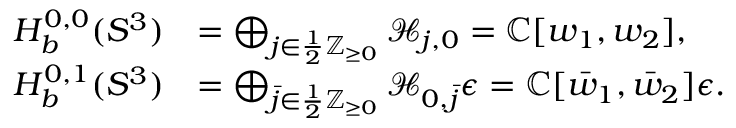Convert formula to latex. <formula><loc_0><loc_0><loc_500><loc_500>\begin{array} { r l } { H _ { b } ^ { 0 , 0 } ( S ^ { 3 } ) } & { = \bigoplus _ { j \in \frac { 1 } { 2 } \mathbb { Z } _ { \geq 0 } } \mathcal { H } _ { j , 0 } = \mathbb { C } [ w _ { 1 } , w _ { 2 } ] , } \\ { H _ { b } ^ { 0 , 1 } ( S ^ { 3 } ) } & { = \bigoplus _ { \bar { j } \in \frac { 1 } { 2 } \mathbb { Z } _ { \geq 0 } } \mathcal { H } _ { 0 , \bar { j } } \epsilon = \mathbb { C } [ \bar { w } _ { 1 } , \bar { w } _ { 2 } ] \epsilon . } \end{array}</formula> 